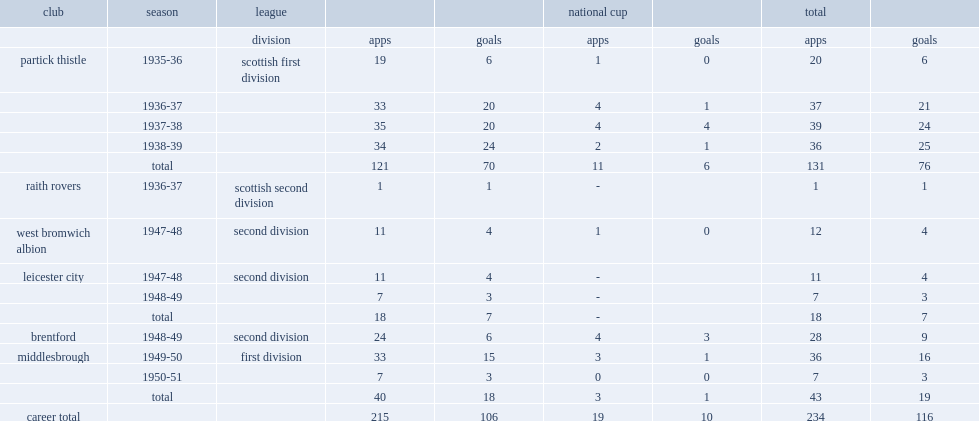How many league goals did peter stewart mckennan score for partick thistle in 121 appearances. 70.0. 